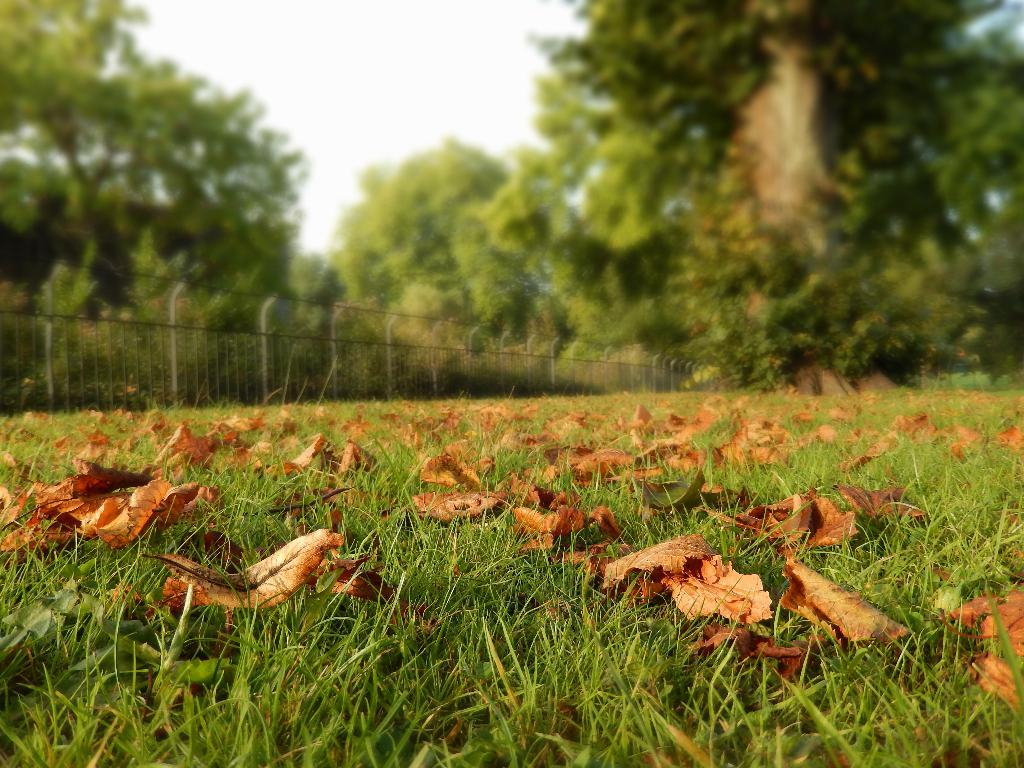What type of vegetation can be seen on the ground in the image? There are dried leaves on the grass in the image. What type of structure is present in the image? There is a fence in the image. What type of natural elements are present in the image? There are trees in the image. What can be seen in the background of the image? The sky is visible in the background of the image. Is there a carpenter working on a tent in the image? There is no carpenter or tent present in the image. What type of neck accessory is visible on the trees in the image? There are no neck accessories present on the trees in the image; they are natural elements. 